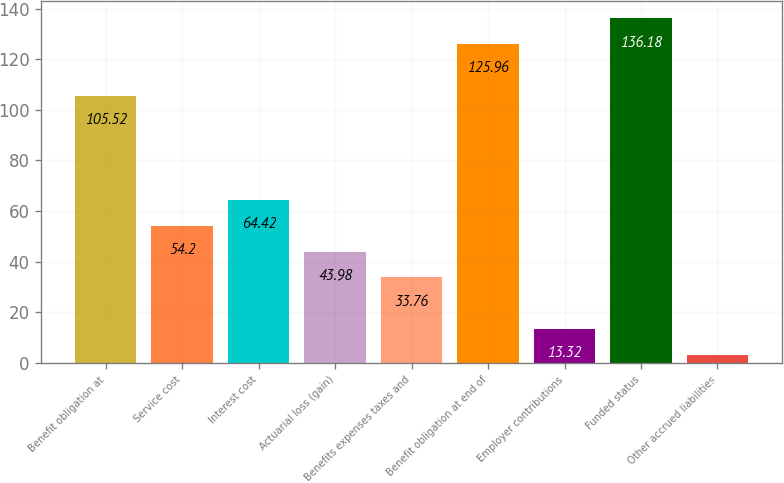Convert chart. <chart><loc_0><loc_0><loc_500><loc_500><bar_chart><fcel>Benefit obligation at<fcel>Service cost<fcel>Interest cost<fcel>Actuarial loss (gain)<fcel>Benefits expenses taxes and<fcel>Benefit obligation at end of<fcel>Employer contributions<fcel>Funded status<fcel>Other accrued liabilities<nl><fcel>105.52<fcel>54.2<fcel>64.42<fcel>43.98<fcel>33.76<fcel>125.96<fcel>13.32<fcel>136.18<fcel>3.1<nl></chart> 